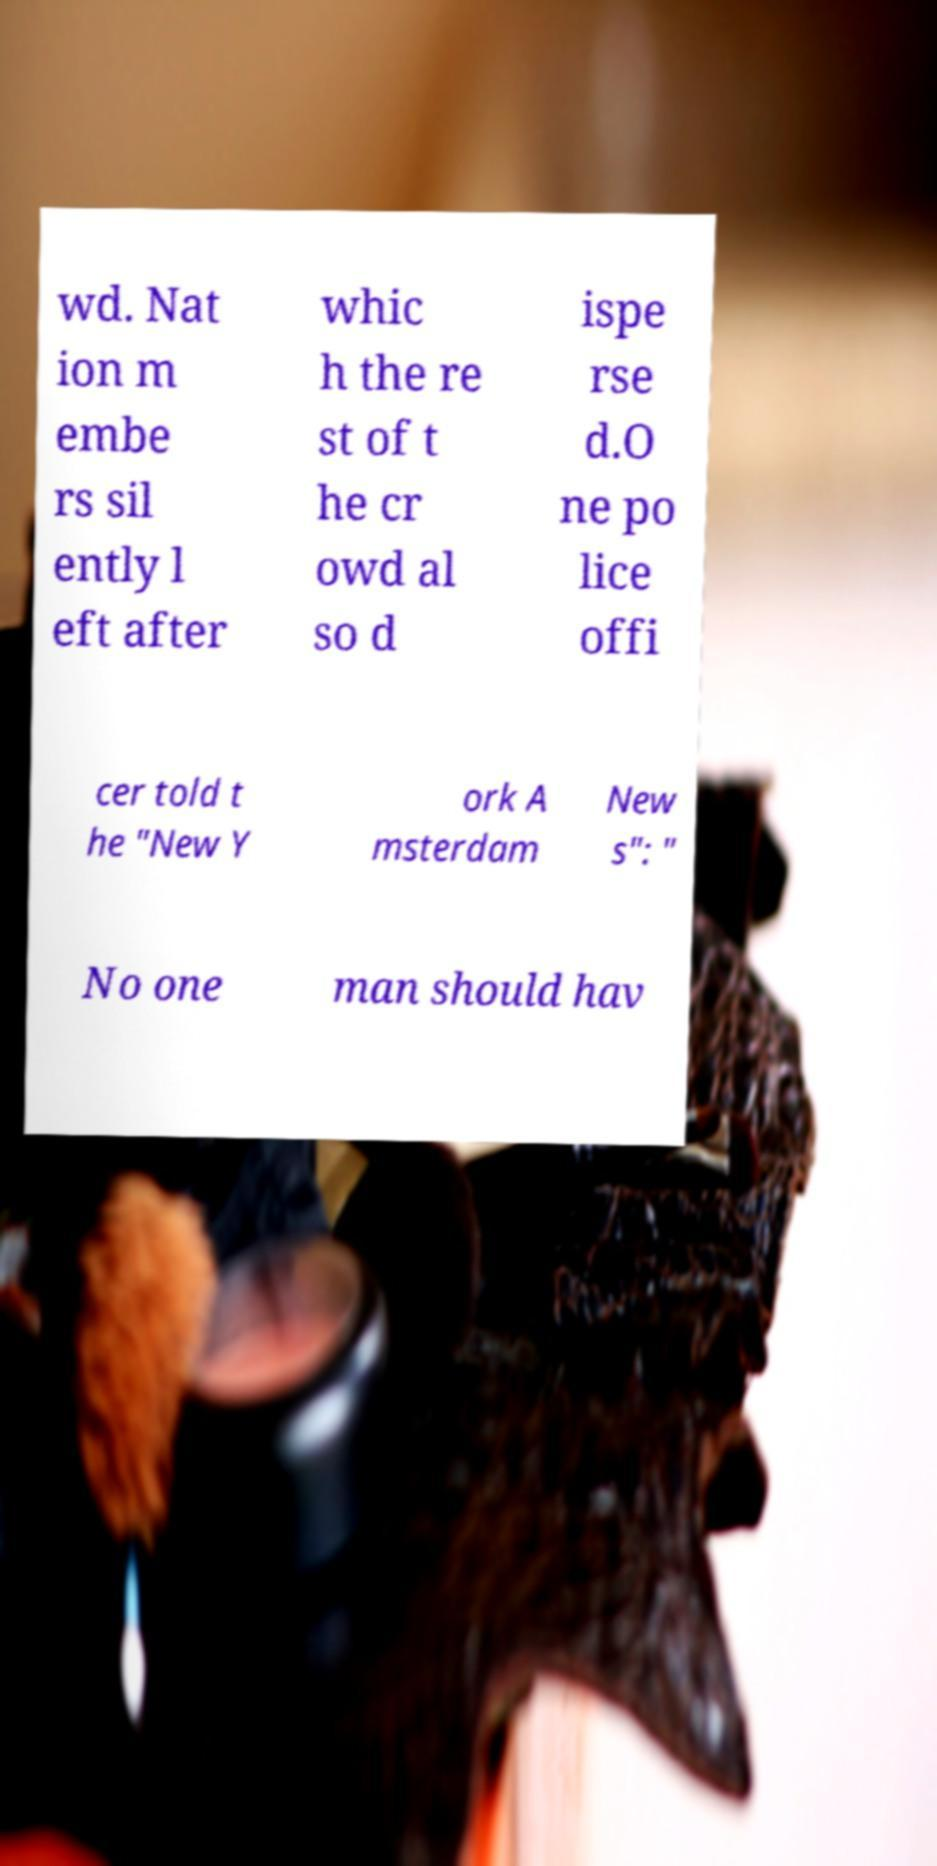What messages or text are displayed in this image? I need them in a readable, typed format. wd. Nat ion m embe rs sil ently l eft after whic h the re st of t he cr owd al so d ispe rse d.O ne po lice offi cer told t he "New Y ork A msterdam New s": " No one man should hav 